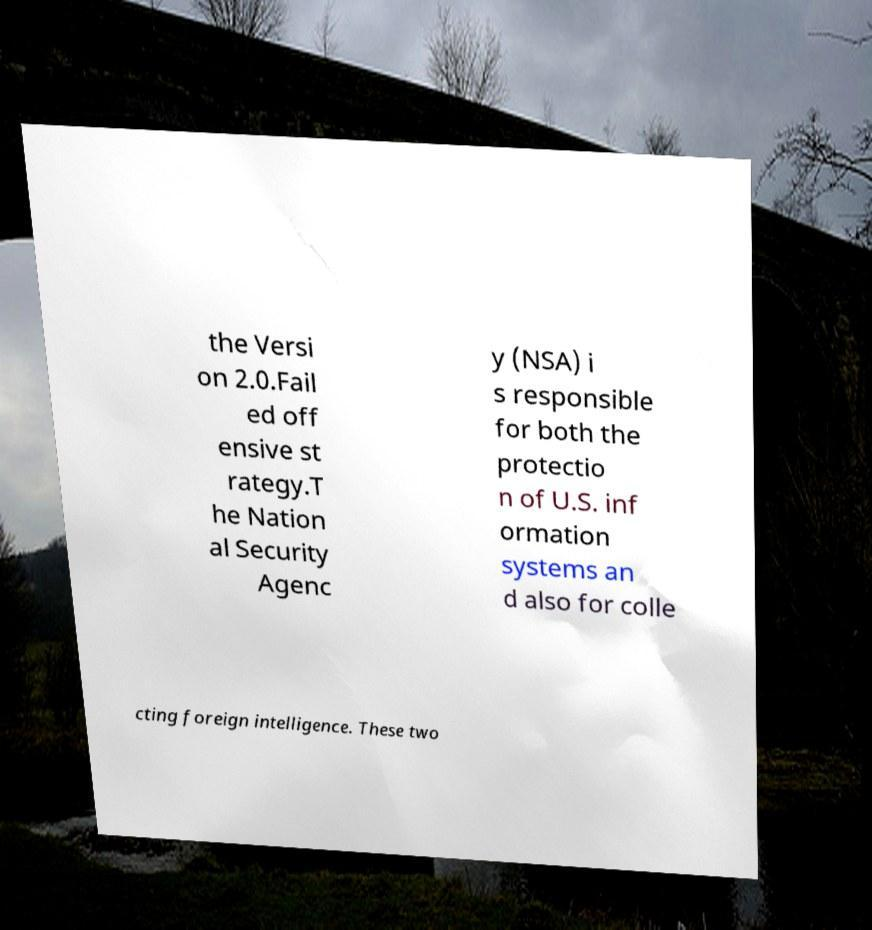Can you read and provide the text displayed in the image?This photo seems to have some interesting text. Can you extract and type it out for me? the Versi on 2.0.Fail ed off ensive st rategy.T he Nation al Security Agenc y (NSA) i s responsible for both the protectio n of U.S. inf ormation systems an d also for colle cting foreign intelligence. These two 